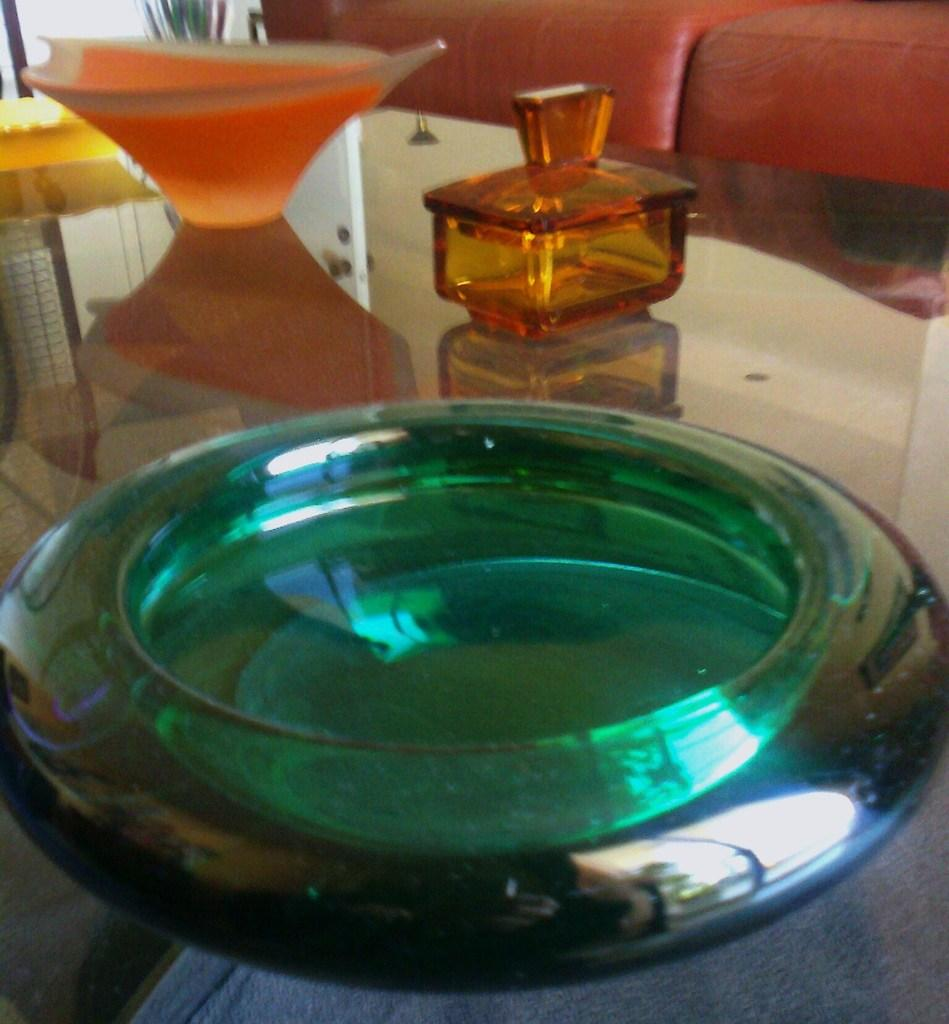What piece of furniture is present in the image? There is a table in the image. What is placed on the table? There is a bowl, a jar, and a vase on the table. Can you describe the background of the image? There is a sofa in the background of the image. Who is the representative of the care and anger in the image? There is no representation of care or anger in the image, as it only features a table, a bowl, a jar, a vase, and a sofa in the background. 